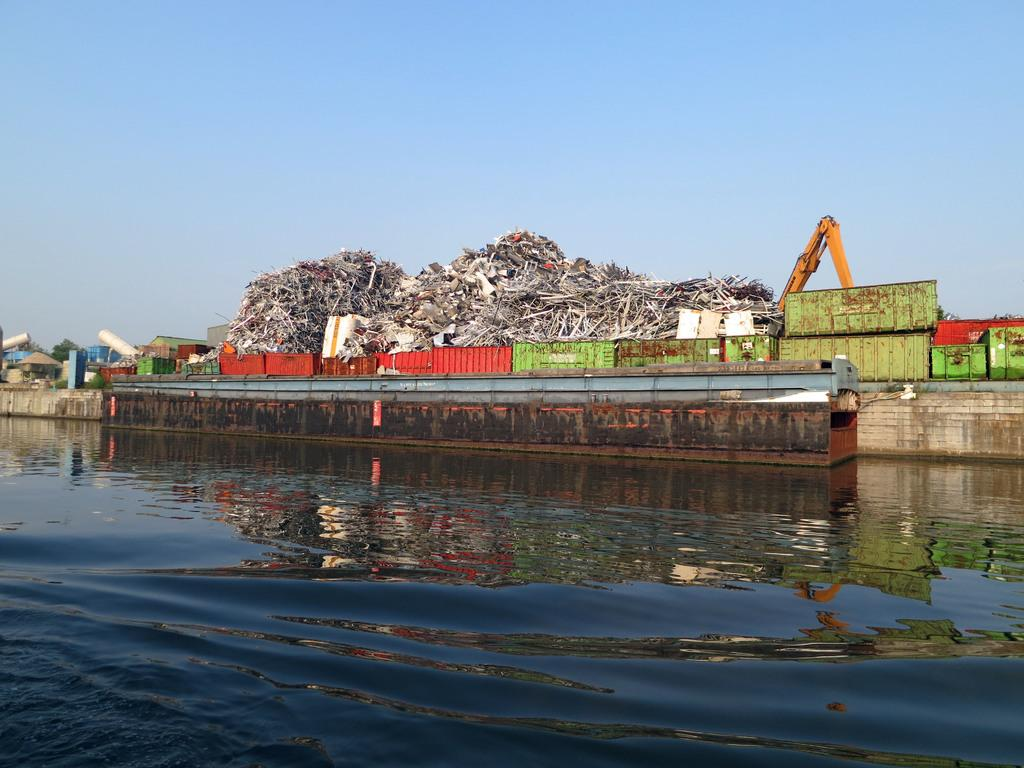What is the main feature of the image? There is water in the image. What structure can be seen crossing the water? There is a bridge in the image. What objects are present near the water? There are containers in the image. What colors are the containers? The containers are in multiple colors. What can be seen in the background of the image? The sky in the background is blue. Why is the table crying in the image? There is no table present in the image, let alone a crying one. 